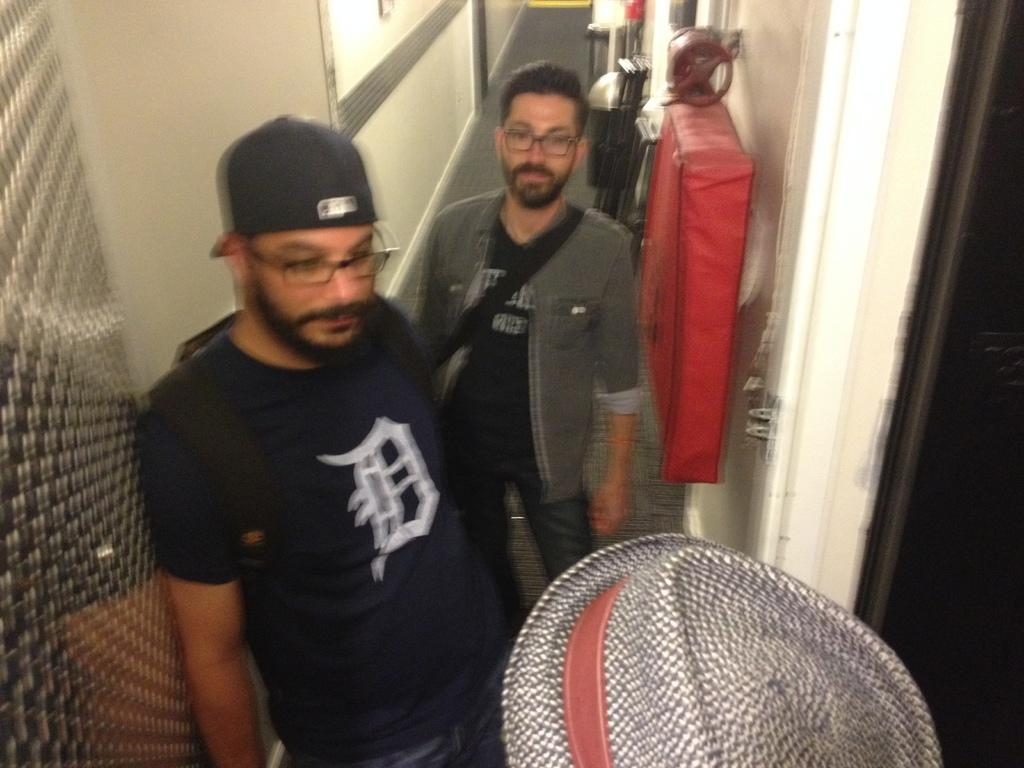What is the main subject of the image? The main subject of the image is people in the center. What architectural feature can be seen at the top side of the image? There is a window at the top side of the image. What is located on the right side of the image? There is a door on the right side of the image. What type of wound can be seen on the potato in the image? There is no potato or wound present in the image. 